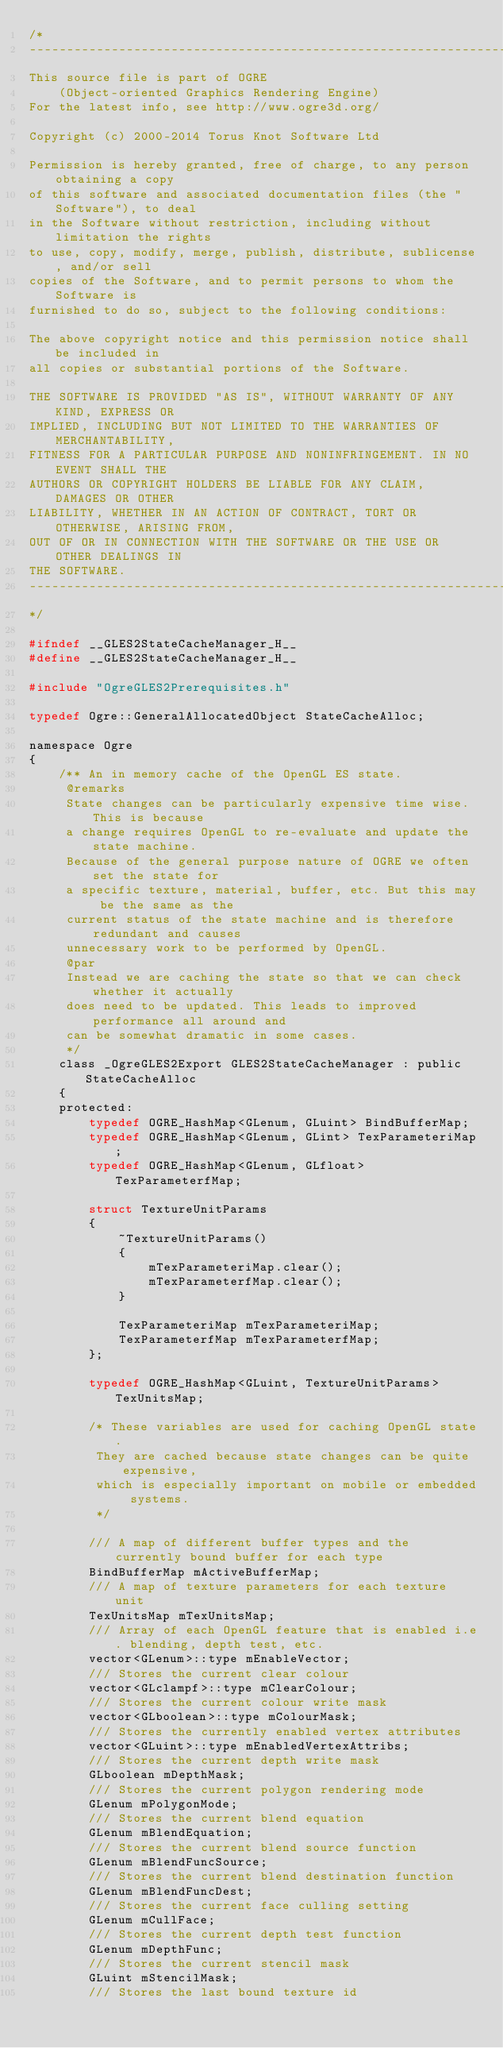<code> <loc_0><loc_0><loc_500><loc_500><_C_>/*
-----------------------------------------------------------------------------
This source file is part of OGRE
    (Object-oriented Graphics Rendering Engine)
For the latest info, see http://www.ogre3d.org/

Copyright (c) 2000-2014 Torus Knot Software Ltd

Permission is hereby granted, free of charge, to any person obtaining a copy
of this software and associated documentation files (the "Software"), to deal
in the Software without restriction, including without limitation the rights
to use, copy, modify, merge, publish, distribute, sublicense, and/or sell
copies of the Software, and to permit persons to whom the Software is
furnished to do so, subject to the following conditions:

The above copyright notice and this permission notice shall be included in
all copies or substantial portions of the Software.

THE SOFTWARE IS PROVIDED "AS IS", WITHOUT WARRANTY OF ANY KIND, EXPRESS OR
IMPLIED, INCLUDING BUT NOT LIMITED TO THE WARRANTIES OF MERCHANTABILITY,
FITNESS FOR A PARTICULAR PURPOSE AND NONINFRINGEMENT. IN NO EVENT SHALL THE
AUTHORS OR COPYRIGHT HOLDERS BE LIABLE FOR ANY CLAIM, DAMAGES OR OTHER
LIABILITY, WHETHER IN AN ACTION OF CONTRACT, TORT OR OTHERWISE, ARISING FROM,
OUT OF OR IN CONNECTION WITH THE SOFTWARE OR THE USE OR OTHER DEALINGS IN
THE SOFTWARE.
-----------------------------------------------------------------------------
*/

#ifndef __GLES2StateCacheManager_H__
#define __GLES2StateCacheManager_H__

#include "OgreGLES2Prerequisites.h"

typedef Ogre::GeneralAllocatedObject StateCacheAlloc;

namespace Ogre
{
    /** An in memory cache of the OpenGL ES state.
     @remarks
     State changes can be particularly expensive time wise. This is because
     a change requires OpenGL to re-evaluate and update the state machine.
     Because of the general purpose nature of OGRE we often set the state for
     a specific texture, material, buffer, etc. But this may be the same as the
     current status of the state machine and is therefore redundant and causes
     unnecessary work to be performed by OpenGL.
     @par
     Instead we are caching the state so that we can check whether it actually
     does need to be updated. This leads to improved performance all around and 
     can be somewhat dramatic in some cases.
     */
    class _OgreGLES2Export GLES2StateCacheManager : public StateCacheAlloc
    {
    protected:
        typedef OGRE_HashMap<GLenum, GLuint> BindBufferMap;
        typedef OGRE_HashMap<GLenum, GLint> TexParameteriMap;
        typedef OGRE_HashMap<GLenum, GLfloat> TexParameterfMap;

        struct TextureUnitParams
        {
            ~TextureUnitParams()
            {
                mTexParameteriMap.clear();
                mTexParameterfMap.clear();
            }

            TexParameteriMap mTexParameteriMap;
            TexParameterfMap mTexParameterfMap;
        };

        typedef OGRE_HashMap<GLuint, TextureUnitParams> TexUnitsMap;

        /* These variables are used for caching OpenGL state.
         They are cached because state changes can be quite expensive,
         which is especially important on mobile or embedded systems.
         */

        /// A map of different buffer types and the currently bound buffer for each type
        BindBufferMap mActiveBufferMap;
        /// A map of texture parameters for each texture unit
        TexUnitsMap mTexUnitsMap;
        /// Array of each OpenGL feature that is enabled i.e. blending, depth test, etc.
        vector<GLenum>::type mEnableVector;
        /// Stores the current clear colour
        vector<GLclampf>::type mClearColour;
        /// Stores the current colour write mask
        vector<GLboolean>::type mColourMask;
        /// Stores the currently enabled vertex attributes
        vector<GLuint>::type mEnabledVertexAttribs;
        /// Stores the current depth write mask
        GLboolean mDepthMask;
        /// Stores the current polygon rendering mode
        GLenum mPolygonMode;
        /// Stores the current blend equation
        GLenum mBlendEquation;
        /// Stores the current blend source function
        GLenum mBlendFuncSource;
        /// Stores the current blend destination function
        GLenum mBlendFuncDest;
        /// Stores the current face culling setting
        GLenum mCullFace;
        /// Stores the current depth test function
        GLenum mDepthFunc;
        /// Stores the current stencil mask
        GLuint mStencilMask;
        /// Stores the last bound texture id</code> 